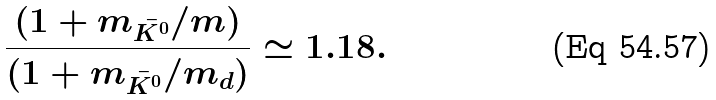<formula> <loc_0><loc_0><loc_500><loc_500>\frac { ( 1 + m _ { \bar { K ^ { 0 } } } / m ) } { ( 1 + m _ { \bar { K ^ { 0 } } } / m _ { d } ) } \simeq 1 . 1 8 .</formula> 